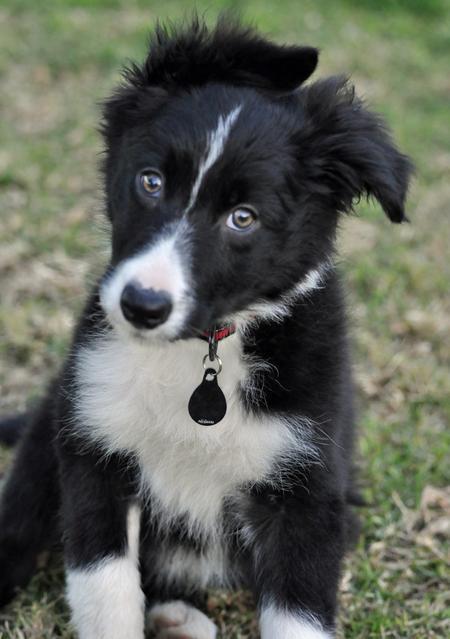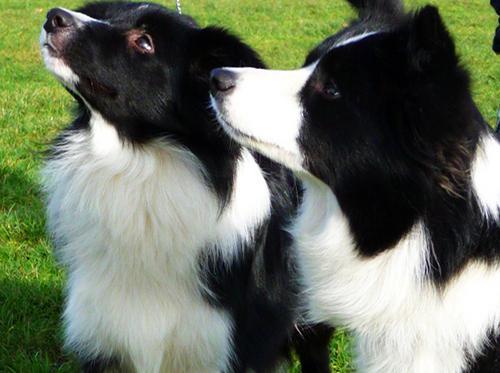The first image is the image on the left, the second image is the image on the right. Given the left and right images, does the statement "A dog in one image has one white eye and one black eye." hold true? Answer yes or no. No. 